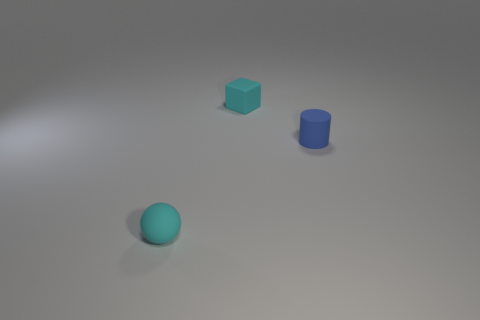Add 2 cyan shiny cubes. How many objects exist? 5 Subtract all cubes. How many objects are left? 2 Add 3 small red blocks. How many small red blocks exist? 3 Subtract 0 gray cylinders. How many objects are left? 3 Subtract all large purple matte spheres. Subtract all small cyan objects. How many objects are left? 1 Add 1 tiny cyan matte spheres. How many tiny cyan matte spheres are left? 2 